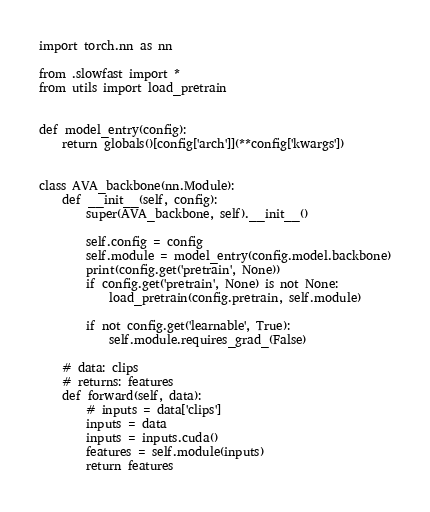Convert code to text. <code><loc_0><loc_0><loc_500><loc_500><_Python_>import torch.nn as nn

from .slowfast import *
from utils import load_pretrain


def model_entry(config):
    return globals()[config['arch']](**config['kwargs'])


class AVA_backbone(nn.Module):
    def __init__(self, config):
        super(AVA_backbone, self).__init__()
        
        self.config = config
        self.module = model_entry(config.model.backbone)
        print(config.get('pretrain', None))
        if config.get('pretrain', None) is not None:
            load_pretrain(config.pretrain, self.module)
                
        if not config.get('learnable', True):
            self.module.requires_grad_(False)

    # data: clips
    # returns: features
    def forward(self, data):
        # inputs = data['clips']
        inputs = data
        inputs = inputs.cuda()
        features = self.module(inputs)
        return features
</code> 